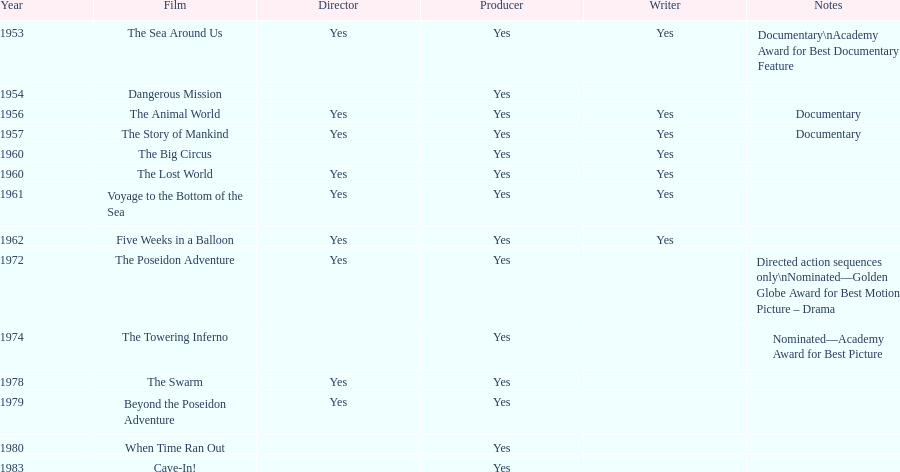How many films did irwin allen direct, produce and write? 6. 